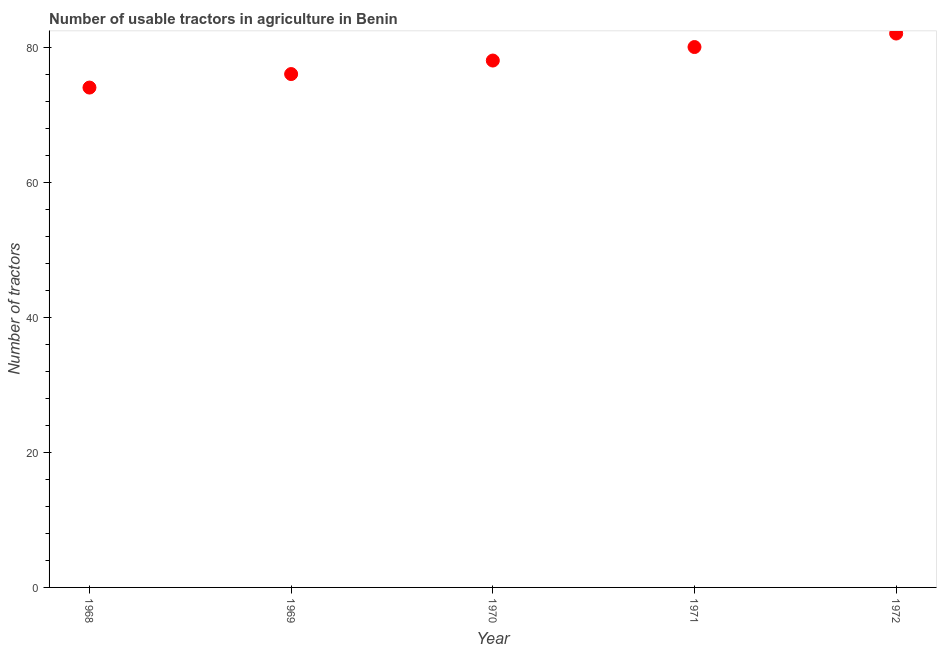What is the number of tractors in 1968?
Provide a short and direct response. 74. Across all years, what is the maximum number of tractors?
Offer a terse response. 82. Across all years, what is the minimum number of tractors?
Keep it short and to the point. 74. In which year was the number of tractors minimum?
Offer a very short reply. 1968. What is the sum of the number of tractors?
Give a very brief answer. 390. What is the difference between the number of tractors in 1969 and 1970?
Your response must be concise. -2. What is the average number of tractors per year?
Make the answer very short. 78. What is the median number of tractors?
Give a very brief answer. 78. In how many years, is the number of tractors greater than 68 ?
Your answer should be very brief. 5. What is the ratio of the number of tractors in 1971 to that in 1972?
Offer a very short reply. 0.98. Is the number of tractors in 1968 less than that in 1970?
Make the answer very short. Yes. What is the difference between the highest and the second highest number of tractors?
Provide a succinct answer. 2. Is the sum of the number of tractors in 1971 and 1972 greater than the maximum number of tractors across all years?
Provide a short and direct response. Yes. What is the difference between the highest and the lowest number of tractors?
Keep it short and to the point. 8. Does the number of tractors monotonically increase over the years?
Ensure brevity in your answer.  Yes. How many years are there in the graph?
Your response must be concise. 5. Are the values on the major ticks of Y-axis written in scientific E-notation?
Offer a terse response. No. What is the title of the graph?
Provide a short and direct response. Number of usable tractors in agriculture in Benin. What is the label or title of the Y-axis?
Offer a very short reply. Number of tractors. What is the Number of tractors in 1968?
Provide a short and direct response. 74. What is the Number of tractors in 1969?
Your response must be concise. 76. What is the Number of tractors in 1971?
Your response must be concise. 80. What is the Number of tractors in 1972?
Your answer should be very brief. 82. What is the difference between the Number of tractors in 1968 and 1970?
Your answer should be very brief. -4. What is the difference between the Number of tractors in 1968 and 1971?
Provide a succinct answer. -6. What is the difference between the Number of tractors in 1968 and 1972?
Give a very brief answer. -8. What is the difference between the Number of tractors in 1969 and 1971?
Your answer should be very brief. -4. What is the difference between the Number of tractors in 1970 and 1972?
Give a very brief answer. -4. What is the difference between the Number of tractors in 1971 and 1972?
Give a very brief answer. -2. What is the ratio of the Number of tractors in 1968 to that in 1970?
Your answer should be compact. 0.95. What is the ratio of the Number of tractors in 1968 to that in 1971?
Your answer should be compact. 0.93. What is the ratio of the Number of tractors in 1968 to that in 1972?
Give a very brief answer. 0.9. What is the ratio of the Number of tractors in 1969 to that in 1970?
Offer a terse response. 0.97. What is the ratio of the Number of tractors in 1969 to that in 1971?
Ensure brevity in your answer.  0.95. What is the ratio of the Number of tractors in 1969 to that in 1972?
Your answer should be compact. 0.93. What is the ratio of the Number of tractors in 1970 to that in 1972?
Provide a short and direct response. 0.95. What is the ratio of the Number of tractors in 1971 to that in 1972?
Offer a terse response. 0.98. 